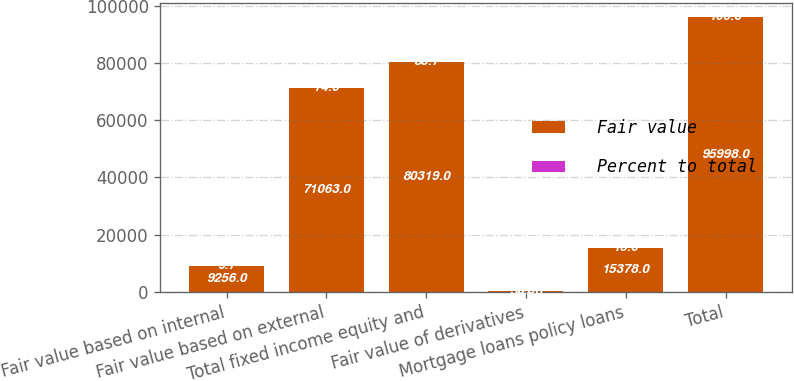Convert chart to OTSL. <chart><loc_0><loc_0><loc_500><loc_500><stacked_bar_chart><ecel><fcel>Fair value based on internal<fcel>Fair value based on external<fcel>Total fixed income equity and<fcel>Fair value of derivatives<fcel>Mortgage loans policy loans<fcel>Total<nl><fcel>Fair value<fcel>9256<fcel>71063<fcel>80319<fcel>301<fcel>15378<fcel>95998<nl><fcel>Percent to total<fcel>9.7<fcel>74<fcel>83.7<fcel>0.3<fcel>16<fcel>100<nl></chart> 